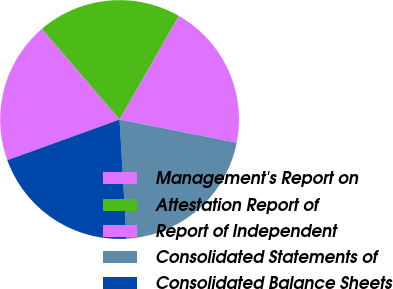<chart> <loc_0><loc_0><loc_500><loc_500><pie_chart><fcel>Management's Report on<fcel>Attestation Report of<fcel>Report of Independent<fcel>Consolidated Statements of<fcel>Consolidated Balance Sheets<nl><fcel>19.26%<fcel>19.55%<fcel>19.83%<fcel>20.96%<fcel>20.4%<nl></chart> 